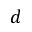Convert formula to latex. <formula><loc_0><loc_0><loc_500><loc_500>d</formula> 